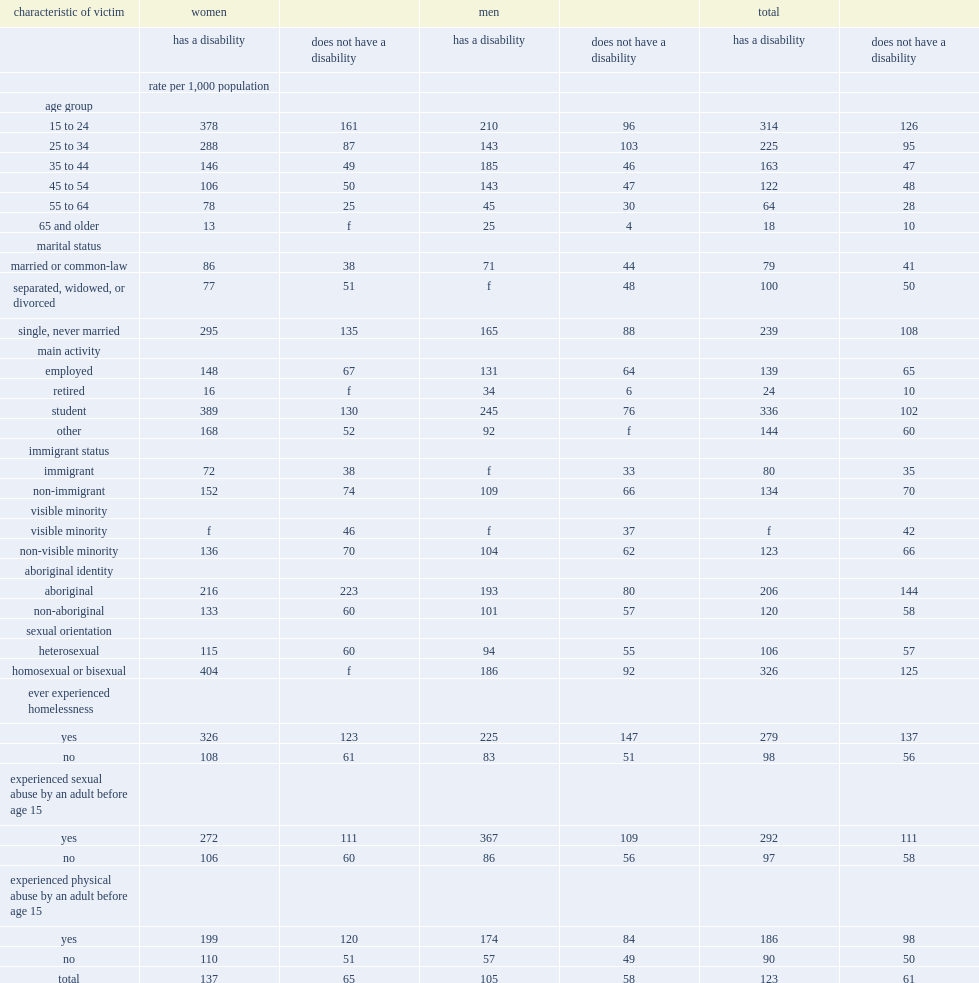How many incidents of violent victimization for every 1,000 women 15 to 24 years of age with a disability? 378.0. Among men with a disability, what was the victimization rates incidents per 1,000 population among those aged 55 to 64? 45.0. Among men with a disability, what was the victimization rates incidents per 1,000 population among those aged 65 years and older? 25.0. How many incidents of violent victimization for every 1,000 women with a disability who were sexually abused during childhood? 272.0. 